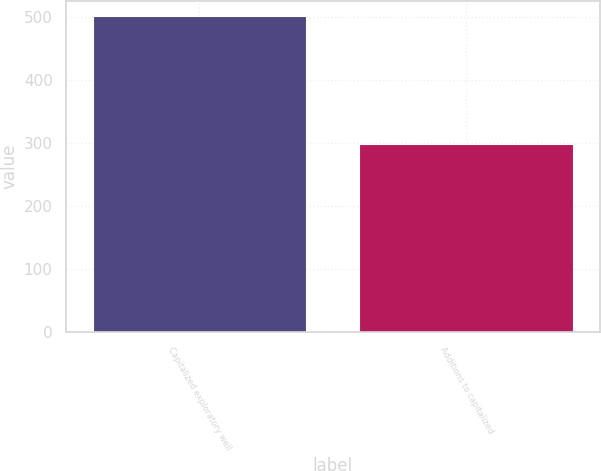<chart> <loc_0><loc_0><loc_500><loc_500><bar_chart><fcel>Capitalized exploratory well<fcel>Additions to capitalized<nl><fcel>501<fcel>299<nl></chart> 